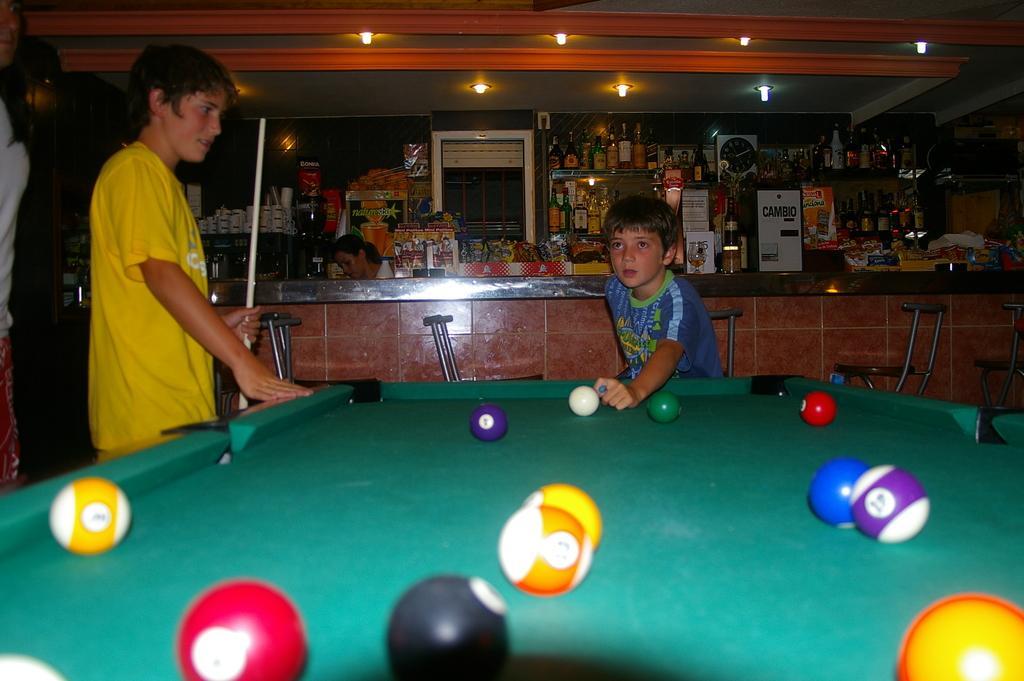Could you give a brief overview of what you see in this image? At the bottom of the image there is a billiard board. There are balls placed on a board. There are two boys standing next to the board. In the background there is a counter. There is a lady sitting in a counter. There are many places bottles placed in the shelves. On the top there are lights. 